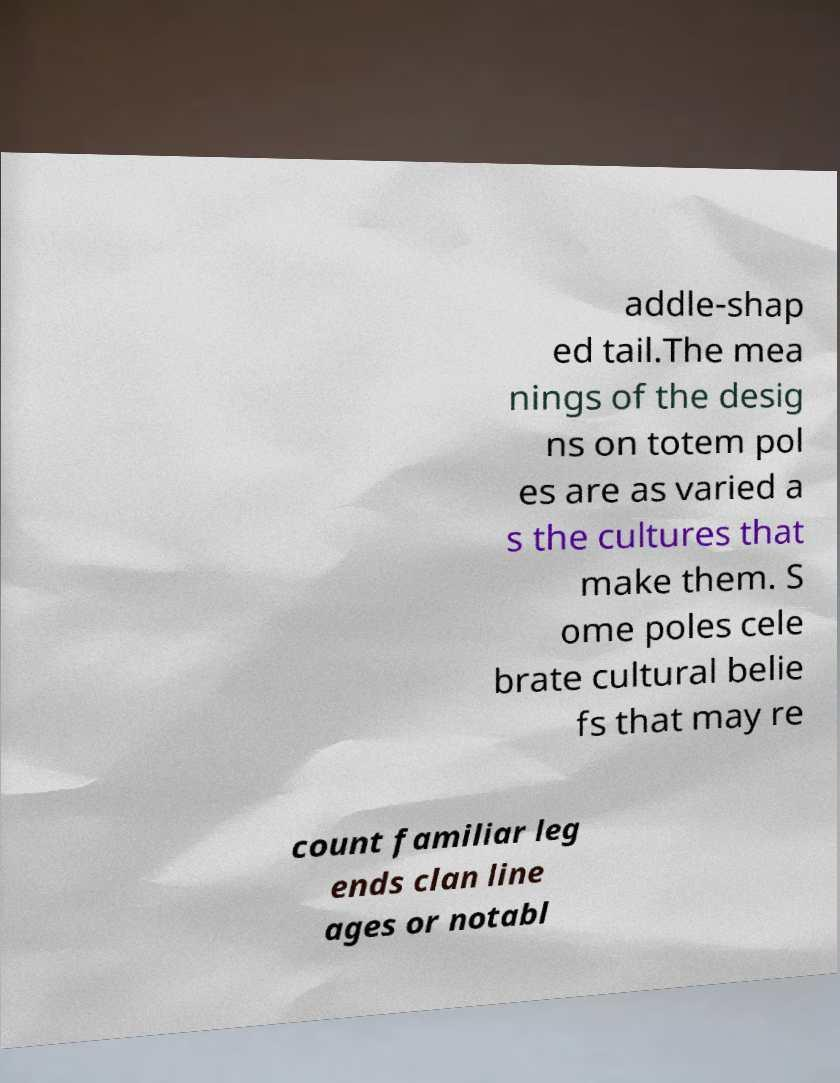Could you extract and type out the text from this image? addle-shap ed tail.The mea nings of the desig ns on totem pol es are as varied a s the cultures that make them. S ome poles cele brate cultural belie fs that may re count familiar leg ends clan line ages or notabl 